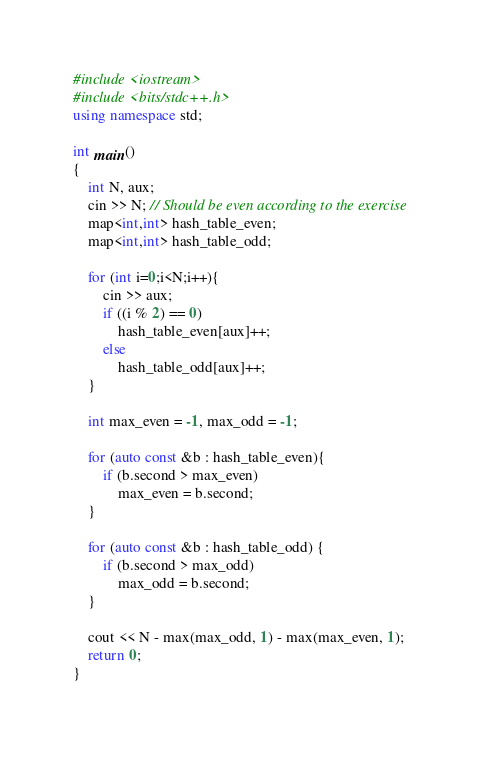<code> <loc_0><loc_0><loc_500><loc_500><_C++_>#include <iostream>
#include <bits/stdc++.h>
using namespace std;

int main()
{
	int N, aux;
	cin >> N; // Should be even according to the exercise
	map<int,int> hash_table_even;
	map<int,int> hash_table_odd;
	
	for (int i=0;i<N;i++){
		cin >> aux;
		if ((i % 2) == 0)
			hash_table_even[aux]++;
		else
			hash_table_odd[aux]++;
	}
	
	int max_even = -1, max_odd = -1;
	
	for (auto const &b : hash_table_even){
		if (b.second > max_even)
			max_even = b.second;
	}
	
	for (auto const &b : hash_table_odd) {
		if (b.second > max_odd)
			max_odd = b.second;
	}
	
	cout << N - max(max_odd, 1) - max(max_even, 1);
	return 0;
}
</code> 